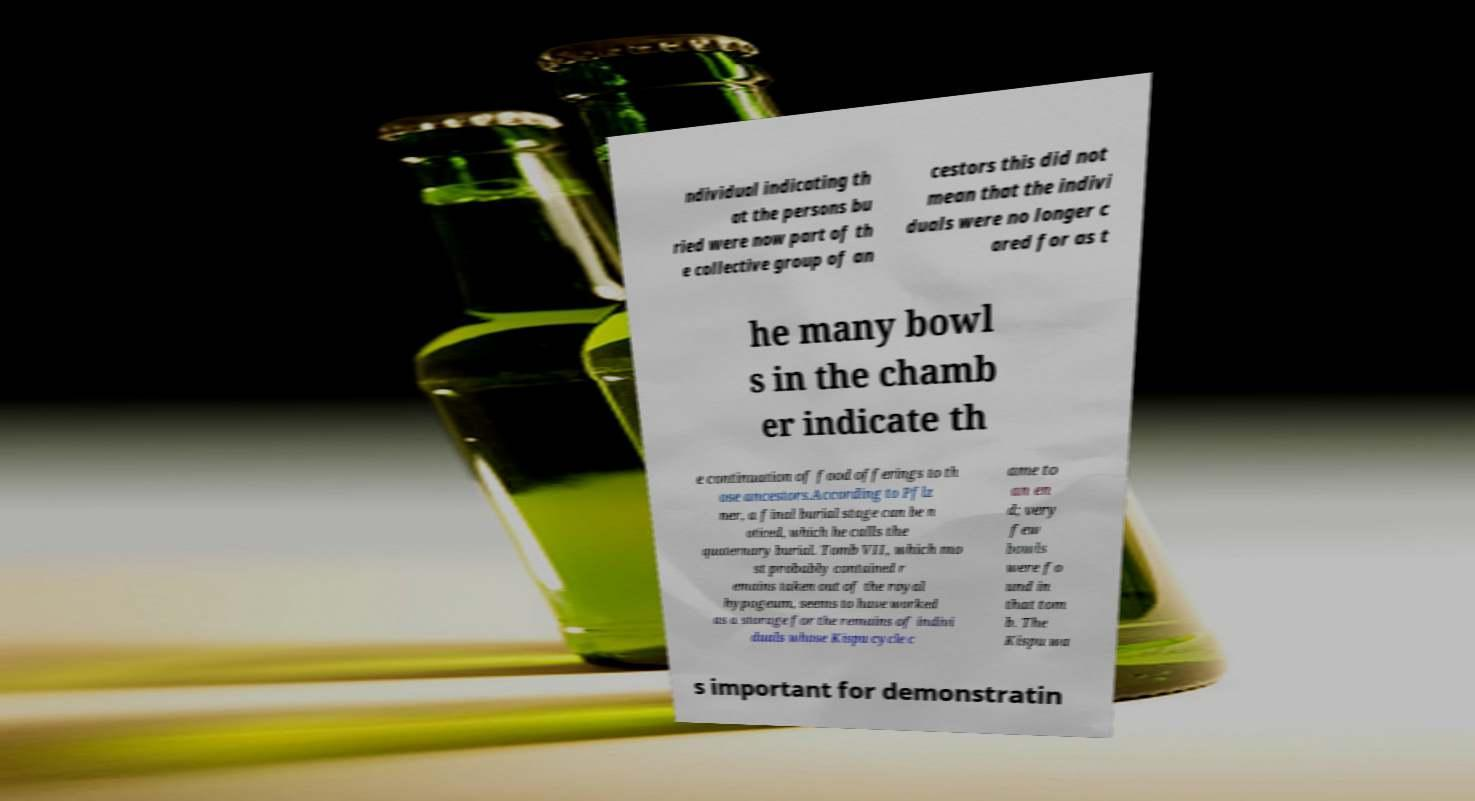Can you accurately transcribe the text from the provided image for me? ndividual indicating th at the persons bu ried were now part of th e collective group of an cestors this did not mean that the indivi duals were no longer c ared for as t he many bowl s in the chamb er indicate th e continuation of food offerings to th ose ancestors.According to Pflz ner, a final burial stage can be n oticed, which he calls the quaternary burial. Tomb VII, which mo st probably contained r emains taken out of the royal hypogeum, seems to have worked as a storage for the remains of indivi duals whose Kispu cycle c ame to an en d; very few bowls were fo und in that tom b. The Kispu wa s important for demonstratin 